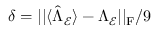<formula> <loc_0><loc_0><loc_500><loc_500>\delta = | | \langle \hat { \Lambda } _ { \mathcal { E } } \rangle - \Lambda _ { \mathcal { E } } | | _ { F } / 9</formula> 